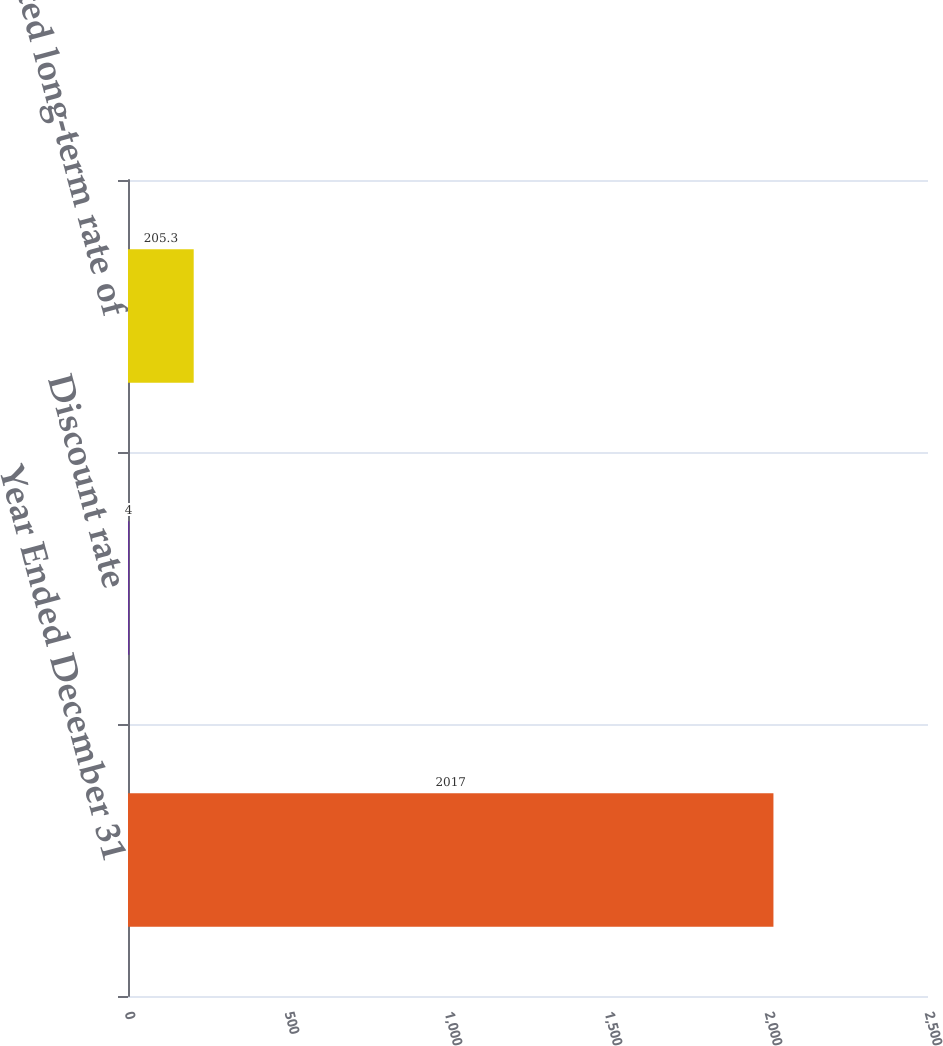Convert chart to OTSL. <chart><loc_0><loc_0><loc_500><loc_500><bar_chart><fcel>Year Ended December 31<fcel>Discount rate<fcel>Expected long-term rate of<nl><fcel>2017<fcel>4<fcel>205.3<nl></chart> 